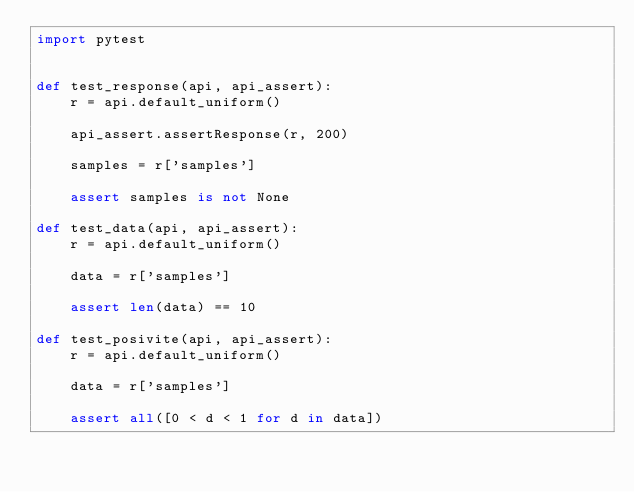Convert code to text. <code><loc_0><loc_0><loc_500><loc_500><_Python_>import pytest


def test_response(api, api_assert):
    r = api.default_uniform()

    api_assert.assertResponse(r, 200)

    samples = r['samples']

    assert samples is not None

def test_data(api, api_assert):
    r = api.default_uniform()

    data = r['samples']

    assert len(data) == 10

def test_posivite(api, api_assert):
    r = api.default_uniform()

    data = r['samples']

    assert all([0 < d < 1 for d in data])
</code> 